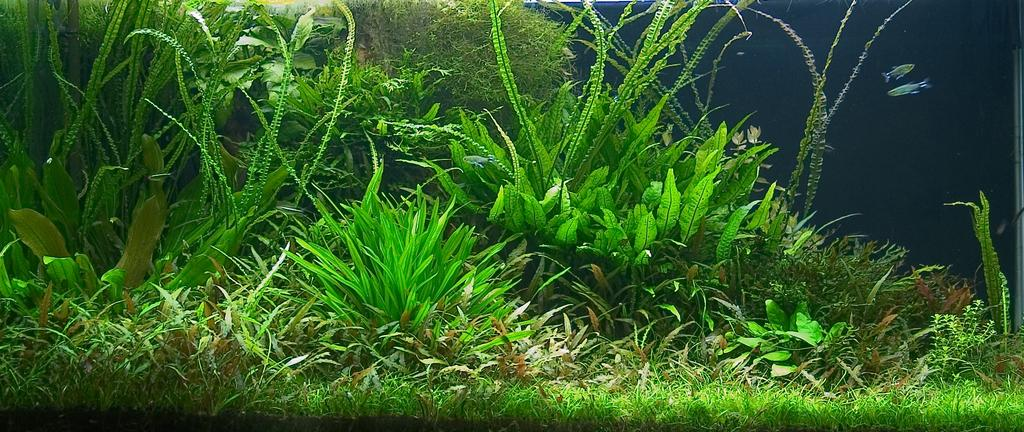What type of living organisms can be seen in the image? There are plants in the image. What color are the plants? The plants are green in color. Are there any animals visible in the image? Yes, there are two fishes on the right side of the image. What type of kite is being worn by the plants in the image? There is no kite present in the image, as the main subjects are plants and fishes. 